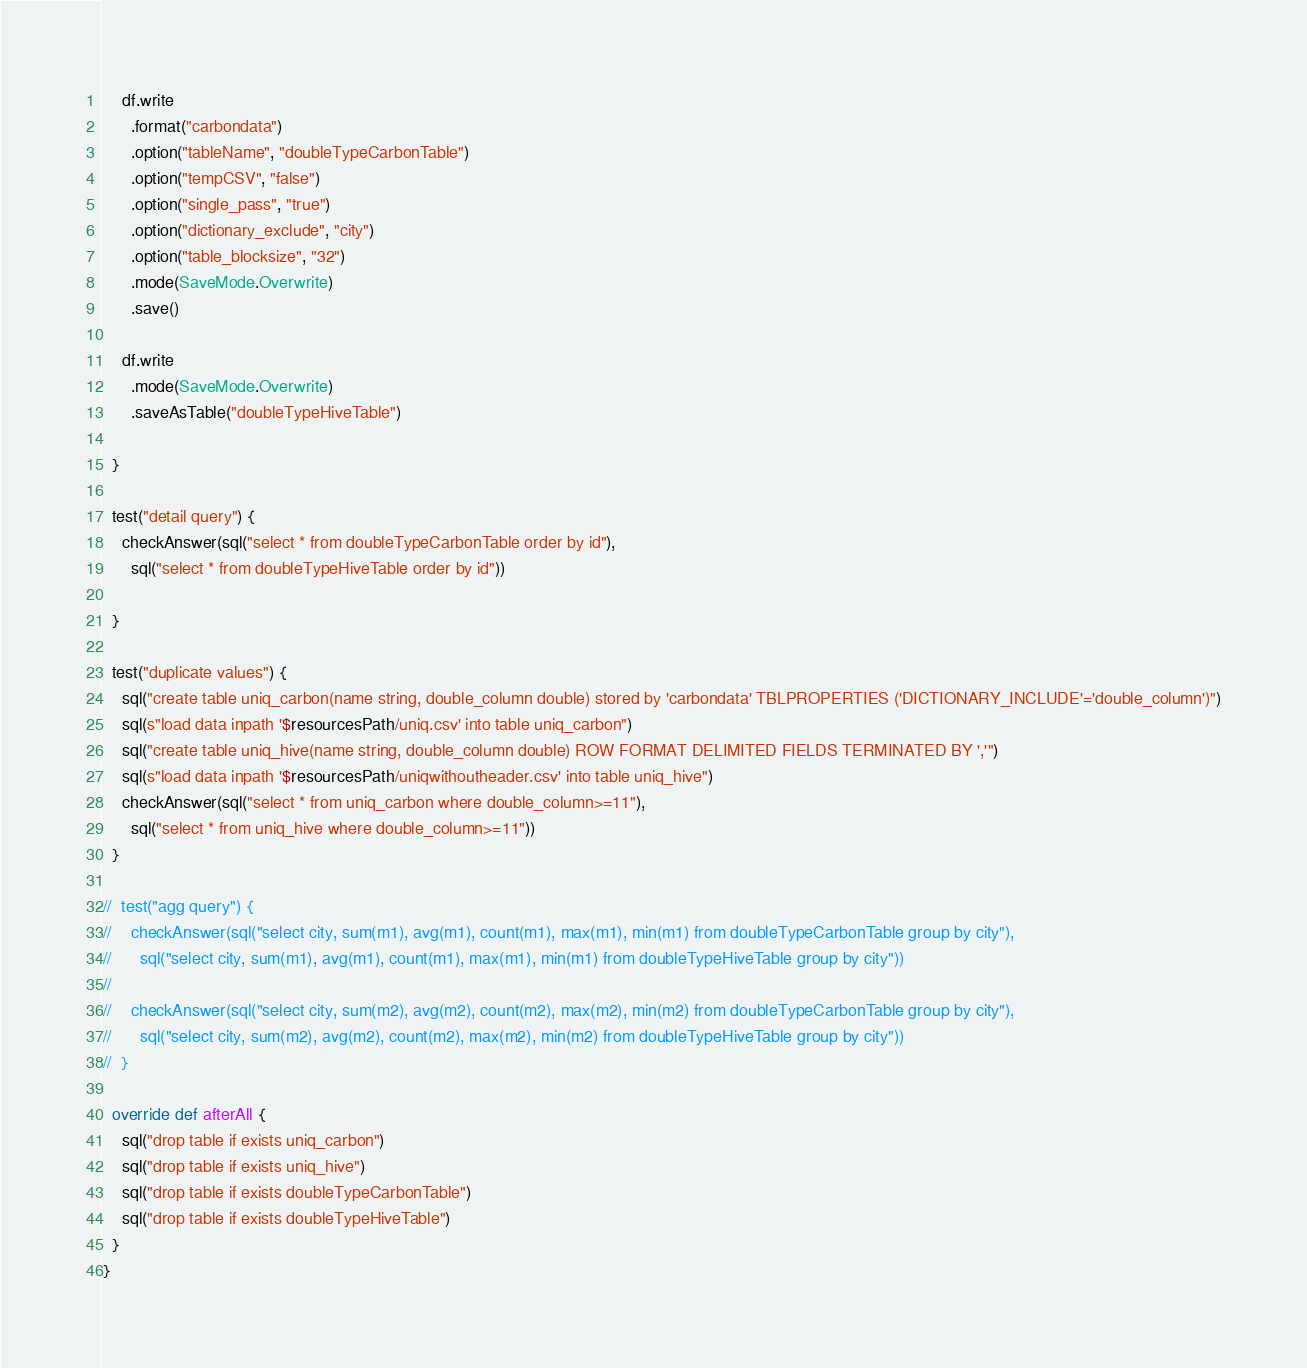<code> <loc_0><loc_0><loc_500><loc_500><_Scala_>
    df.write
      .format("carbondata")
      .option("tableName", "doubleTypeCarbonTable")
      .option("tempCSV", "false")
      .option("single_pass", "true")
      .option("dictionary_exclude", "city")
      .option("table_blocksize", "32")
      .mode(SaveMode.Overwrite)
      .save()

    df.write
      .mode(SaveMode.Overwrite)
      .saveAsTable("doubleTypeHiveTable")

  }

  test("detail query") {
    checkAnswer(sql("select * from doubleTypeCarbonTable order by id"),
      sql("select * from doubleTypeHiveTable order by id"))

  }

  test("duplicate values") {
    sql("create table uniq_carbon(name string, double_column double) stored by 'carbondata' TBLPROPERTIES ('DICTIONARY_INCLUDE'='double_column')")
    sql(s"load data inpath '$resourcesPath/uniq.csv' into table uniq_carbon")
    sql("create table uniq_hive(name string, double_column double) ROW FORMAT DELIMITED FIELDS TERMINATED BY ','")
    sql(s"load data inpath '$resourcesPath/uniqwithoutheader.csv' into table uniq_hive")
    checkAnswer(sql("select * from uniq_carbon where double_column>=11"),
      sql("select * from uniq_hive where double_column>=11"))
  }

//  test("agg query") {
//    checkAnswer(sql("select city, sum(m1), avg(m1), count(m1), max(m1), min(m1) from doubleTypeCarbonTable group by city"),
//      sql("select city, sum(m1), avg(m1), count(m1), max(m1), min(m1) from doubleTypeHiveTable group by city"))
//
//    checkAnswer(sql("select city, sum(m2), avg(m2), count(m2), max(m2), min(m2) from doubleTypeCarbonTable group by city"),
//      sql("select city, sum(m2), avg(m2), count(m2), max(m2), min(m2) from doubleTypeHiveTable group by city"))
//  }

  override def afterAll {
    sql("drop table if exists uniq_carbon")
    sql("drop table if exists uniq_hive")
    sql("drop table if exists doubleTypeCarbonTable")
    sql("drop table if exists doubleTypeHiveTable")
  }
}</code> 